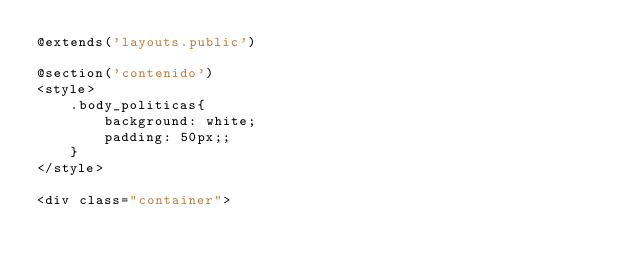Convert code to text. <code><loc_0><loc_0><loc_500><loc_500><_PHP_>@extends('layouts.public')

@section('contenido')
<style>
    .body_politicas{
        background: white;
        padding: 50px;;
    }
</style>

<div class="container"></code> 